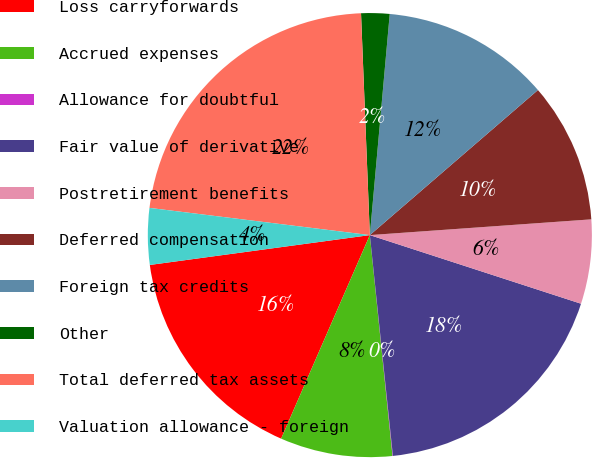<chart> <loc_0><loc_0><loc_500><loc_500><pie_chart><fcel>Loss carryforwards<fcel>Accrued expenses<fcel>Allowance for doubtful<fcel>Fair value of derivative<fcel>Postretirement benefits<fcel>Deferred compensation<fcel>Foreign tax credits<fcel>Other<fcel>Total deferred tax assets<fcel>Valuation allowance - foreign<nl><fcel>16.31%<fcel>8.17%<fcel>0.03%<fcel>18.34%<fcel>6.13%<fcel>10.2%<fcel>12.24%<fcel>2.06%<fcel>22.41%<fcel>4.1%<nl></chart> 